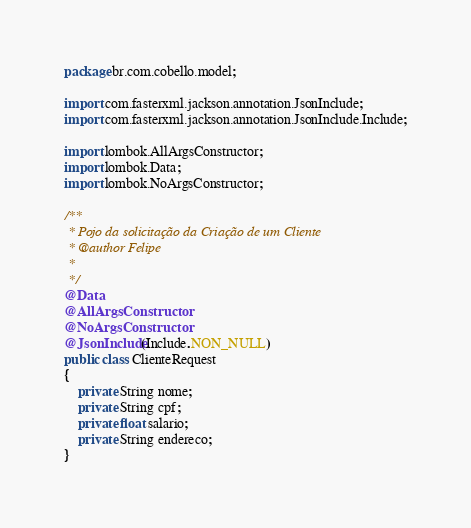Convert code to text. <code><loc_0><loc_0><loc_500><loc_500><_Java_>package br.com.cobello.model;

import com.fasterxml.jackson.annotation.JsonInclude;
import com.fasterxml.jackson.annotation.JsonInclude.Include;

import lombok.AllArgsConstructor;
import lombok.Data;
import lombok.NoArgsConstructor;

/**
 * Pojo da solicitação da Criação de um Cliente
 * @author Felipe
 *
 */
@Data
@AllArgsConstructor
@NoArgsConstructor
@JsonInclude(Include.NON_NULL)
public class ClienteRequest 
{
	private String nome;
	private String cpf;
	private float salario;
	private String endereco;
}
</code> 